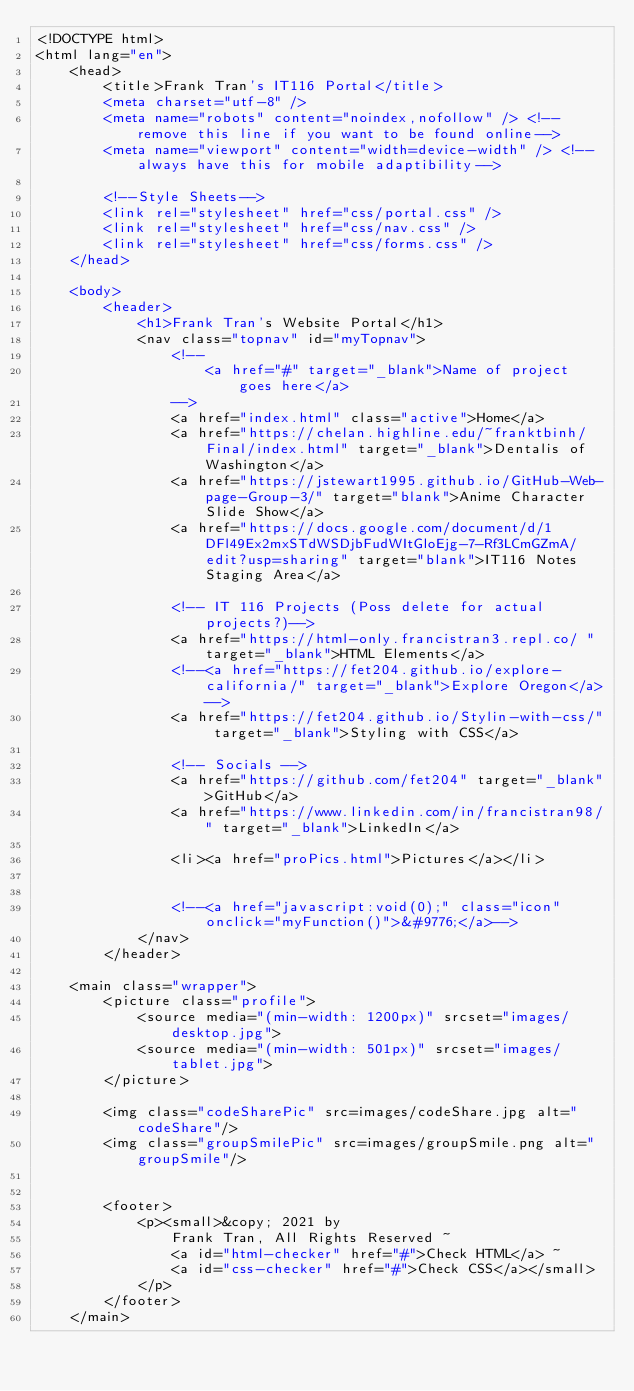<code> <loc_0><loc_0><loc_500><loc_500><_HTML_><!DOCTYPE html>
<html lang="en">
    <head>
        <title>Frank Tran's IT116 Portal</title>
        <meta charset="utf-8" />
        <meta name="robots" content="noindex,nofollow" /> <!--remove this line if you want to be found online-->
        <meta name="viewport" content="width=device-width" /> <!--always have this for mobile adaptibility-->

        <!--Style Sheets-->
        <link rel="stylesheet" href="css/portal.css" />
        <link rel="stylesheet" href="css/nav.css" />
        <link rel="stylesheet" href="css/forms.css" />
    </head>

    <body>
        <header>
            <h1>Frank Tran's Website Portal</h1>
            <nav class="topnav" id="myTopnav">
                <!--
                    <a href="#" target="_blank">Name of project goes here</a>
                -->
                <a href="index.html" class="active">Home</a>
                <a href="https://chelan.highline.edu/~franktbinh/Final/index.html" target="_blank">Dentalis of Washington</a>
                <a href="https://jstewart1995.github.io/GitHub-Web-page-Group-3/" target="blank">Anime Character Slide Show</a>
                <a href="https://docs.google.com/document/d/1DFl49Ex2mxSTdWSDjbFudWItGloEjg-7-Rf3LCmGZmA/edit?usp=sharing" target="blank">IT116 Notes Staging Area</a>

                <!-- IT 116 Projects (Poss delete for actual projects?)-->
                <a href="https://html-only.francistran3.repl.co/ " target="_blank">HTML Elements</a>
                <!--<a href="https://fet204.github.io/explore-california/" target="_blank">Explore Oregon</a>-->
                <a href="https://fet204.github.io/Stylin-with-css/" target="_blank">Styling with CSS</a>

                <!-- Socials -->
                <a href="https://github.com/fet204" target="_blank">GitHub</a>
                <a href="https://www.linkedin.com/in/francistran98/" target="_blank">LinkedIn</a>

                <li><a href="proPics.html">Pictures</a></li>


                <!--<a href="javascript:void(0);" class="icon" onclick="myFunction()">&#9776;</a>-->
            </nav>
        </header>
     
    <main class="wrapper">
        <picture class="profile">
            <source media="(min-width: 1200px)" srcset="images/desktop.jpg">
            <source media="(min-width: 501px)" srcset="images/tablet.jpg">
        </picture>   
        
        <img class="codeSharePic" src=images/codeShare.jpg alt="codeShare"/>
        <img class="groupSmilePic" src=images/groupSmile.png alt="groupSmile"/>


        <footer>
            <p><small>&copy; 2021 by 
                Frank Tran, All Rights Reserved ~ 
                <a id="html-checker" href="#">Check HTML</a> ~ 
                <a id="css-checker" href="#">Check CSS</a></small>
            </p>
        </footer>
    </main>
     </code> 